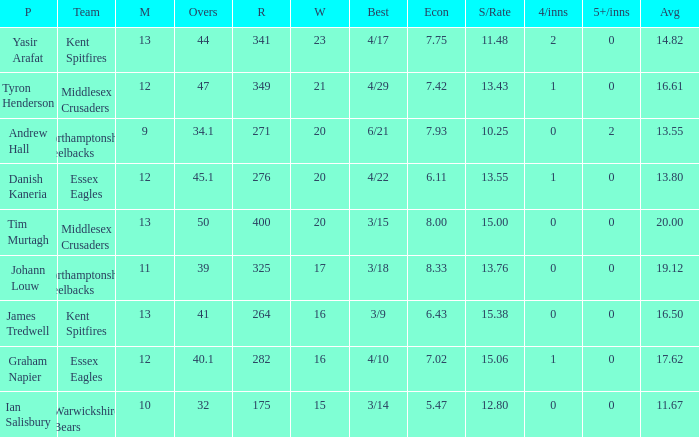Name the most 4/inns 2.0. 